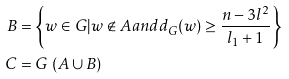Convert formula to latex. <formula><loc_0><loc_0><loc_500><loc_500>B & = \left \{ w \in G | w \not \in A a n d d _ { G } ( w ) \geq \frac { n - 3 l ^ { 2 } } { l _ { 1 } + 1 } \right \} \\ C & = G \ ( A \cup B )</formula> 